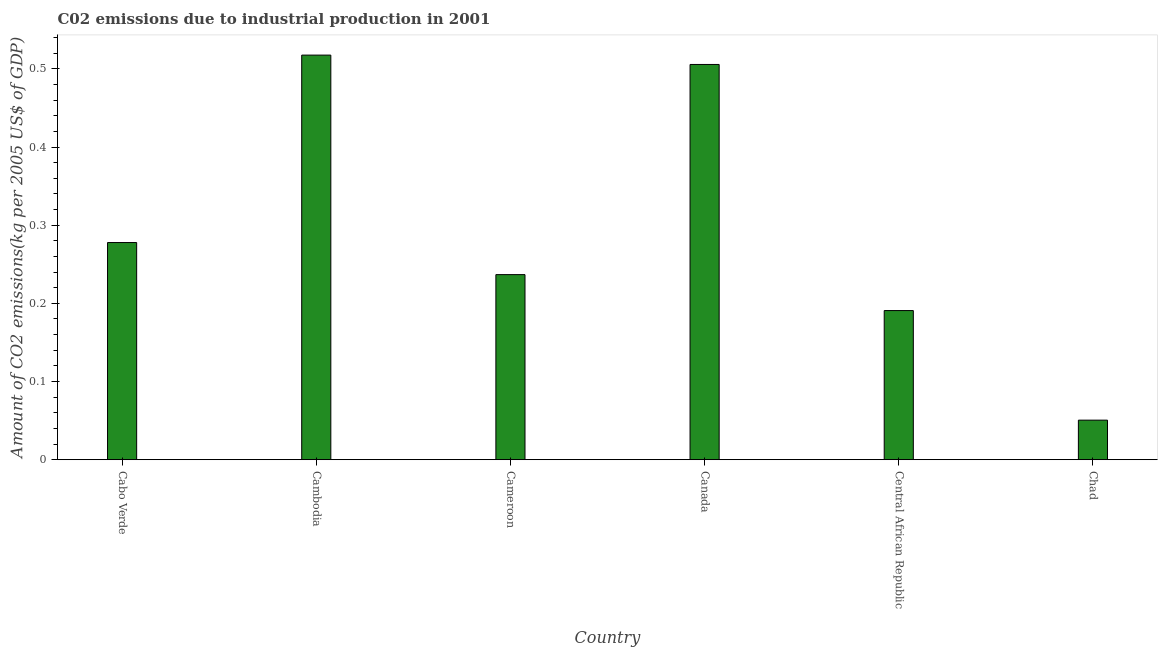Does the graph contain any zero values?
Keep it short and to the point. No. Does the graph contain grids?
Keep it short and to the point. No. What is the title of the graph?
Provide a short and direct response. C02 emissions due to industrial production in 2001. What is the label or title of the X-axis?
Offer a terse response. Country. What is the label or title of the Y-axis?
Your response must be concise. Amount of CO2 emissions(kg per 2005 US$ of GDP). What is the amount of co2 emissions in Cambodia?
Your response must be concise. 0.52. Across all countries, what is the maximum amount of co2 emissions?
Provide a succinct answer. 0.52. Across all countries, what is the minimum amount of co2 emissions?
Make the answer very short. 0.05. In which country was the amount of co2 emissions maximum?
Make the answer very short. Cambodia. In which country was the amount of co2 emissions minimum?
Your response must be concise. Chad. What is the sum of the amount of co2 emissions?
Offer a very short reply. 1.78. What is the difference between the amount of co2 emissions in Cameroon and Central African Republic?
Provide a short and direct response. 0.05. What is the average amount of co2 emissions per country?
Ensure brevity in your answer.  0.3. What is the median amount of co2 emissions?
Make the answer very short. 0.26. In how many countries, is the amount of co2 emissions greater than 0.5 kg per 2005 US$ of GDP?
Keep it short and to the point. 2. What is the ratio of the amount of co2 emissions in Cabo Verde to that in Chad?
Ensure brevity in your answer.  5.49. Is the amount of co2 emissions in Cambodia less than that in Central African Republic?
Your response must be concise. No. Is the difference between the amount of co2 emissions in Cabo Verde and Canada greater than the difference between any two countries?
Make the answer very short. No. What is the difference between the highest and the second highest amount of co2 emissions?
Your answer should be compact. 0.01. What is the difference between the highest and the lowest amount of co2 emissions?
Your answer should be compact. 0.47. How many bars are there?
Ensure brevity in your answer.  6. How many countries are there in the graph?
Provide a short and direct response. 6. What is the difference between two consecutive major ticks on the Y-axis?
Give a very brief answer. 0.1. Are the values on the major ticks of Y-axis written in scientific E-notation?
Make the answer very short. No. What is the Amount of CO2 emissions(kg per 2005 US$ of GDP) of Cabo Verde?
Keep it short and to the point. 0.28. What is the Amount of CO2 emissions(kg per 2005 US$ of GDP) of Cambodia?
Your response must be concise. 0.52. What is the Amount of CO2 emissions(kg per 2005 US$ of GDP) of Cameroon?
Make the answer very short. 0.24. What is the Amount of CO2 emissions(kg per 2005 US$ of GDP) in Canada?
Give a very brief answer. 0.51. What is the Amount of CO2 emissions(kg per 2005 US$ of GDP) in Central African Republic?
Your answer should be compact. 0.19. What is the Amount of CO2 emissions(kg per 2005 US$ of GDP) in Chad?
Your answer should be compact. 0.05. What is the difference between the Amount of CO2 emissions(kg per 2005 US$ of GDP) in Cabo Verde and Cambodia?
Provide a succinct answer. -0.24. What is the difference between the Amount of CO2 emissions(kg per 2005 US$ of GDP) in Cabo Verde and Cameroon?
Keep it short and to the point. 0.04. What is the difference between the Amount of CO2 emissions(kg per 2005 US$ of GDP) in Cabo Verde and Canada?
Provide a succinct answer. -0.23. What is the difference between the Amount of CO2 emissions(kg per 2005 US$ of GDP) in Cabo Verde and Central African Republic?
Your answer should be compact. 0.09. What is the difference between the Amount of CO2 emissions(kg per 2005 US$ of GDP) in Cabo Verde and Chad?
Ensure brevity in your answer.  0.23. What is the difference between the Amount of CO2 emissions(kg per 2005 US$ of GDP) in Cambodia and Cameroon?
Keep it short and to the point. 0.28. What is the difference between the Amount of CO2 emissions(kg per 2005 US$ of GDP) in Cambodia and Canada?
Provide a short and direct response. 0.01. What is the difference between the Amount of CO2 emissions(kg per 2005 US$ of GDP) in Cambodia and Central African Republic?
Keep it short and to the point. 0.33. What is the difference between the Amount of CO2 emissions(kg per 2005 US$ of GDP) in Cambodia and Chad?
Give a very brief answer. 0.47. What is the difference between the Amount of CO2 emissions(kg per 2005 US$ of GDP) in Cameroon and Canada?
Make the answer very short. -0.27. What is the difference between the Amount of CO2 emissions(kg per 2005 US$ of GDP) in Cameroon and Central African Republic?
Keep it short and to the point. 0.05. What is the difference between the Amount of CO2 emissions(kg per 2005 US$ of GDP) in Cameroon and Chad?
Ensure brevity in your answer.  0.19. What is the difference between the Amount of CO2 emissions(kg per 2005 US$ of GDP) in Canada and Central African Republic?
Offer a terse response. 0.31. What is the difference between the Amount of CO2 emissions(kg per 2005 US$ of GDP) in Canada and Chad?
Provide a succinct answer. 0.45. What is the difference between the Amount of CO2 emissions(kg per 2005 US$ of GDP) in Central African Republic and Chad?
Offer a very short reply. 0.14. What is the ratio of the Amount of CO2 emissions(kg per 2005 US$ of GDP) in Cabo Verde to that in Cambodia?
Give a very brief answer. 0.54. What is the ratio of the Amount of CO2 emissions(kg per 2005 US$ of GDP) in Cabo Verde to that in Cameroon?
Provide a succinct answer. 1.17. What is the ratio of the Amount of CO2 emissions(kg per 2005 US$ of GDP) in Cabo Verde to that in Canada?
Provide a short and direct response. 0.55. What is the ratio of the Amount of CO2 emissions(kg per 2005 US$ of GDP) in Cabo Verde to that in Central African Republic?
Keep it short and to the point. 1.46. What is the ratio of the Amount of CO2 emissions(kg per 2005 US$ of GDP) in Cabo Verde to that in Chad?
Offer a very short reply. 5.49. What is the ratio of the Amount of CO2 emissions(kg per 2005 US$ of GDP) in Cambodia to that in Cameroon?
Keep it short and to the point. 2.19. What is the ratio of the Amount of CO2 emissions(kg per 2005 US$ of GDP) in Cambodia to that in Central African Republic?
Offer a terse response. 2.71. What is the ratio of the Amount of CO2 emissions(kg per 2005 US$ of GDP) in Cambodia to that in Chad?
Your answer should be very brief. 10.23. What is the ratio of the Amount of CO2 emissions(kg per 2005 US$ of GDP) in Cameroon to that in Canada?
Your answer should be very brief. 0.47. What is the ratio of the Amount of CO2 emissions(kg per 2005 US$ of GDP) in Cameroon to that in Central African Republic?
Your answer should be very brief. 1.24. What is the ratio of the Amount of CO2 emissions(kg per 2005 US$ of GDP) in Cameroon to that in Chad?
Give a very brief answer. 4.68. What is the ratio of the Amount of CO2 emissions(kg per 2005 US$ of GDP) in Canada to that in Central African Republic?
Keep it short and to the point. 2.65. What is the ratio of the Amount of CO2 emissions(kg per 2005 US$ of GDP) in Canada to that in Chad?
Provide a short and direct response. 9.99. What is the ratio of the Amount of CO2 emissions(kg per 2005 US$ of GDP) in Central African Republic to that in Chad?
Offer a terse response. 3.77. 